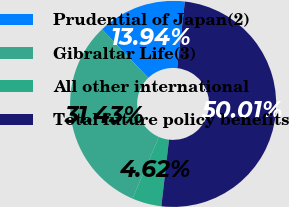Convert chart to OTSL. <chart><loc_0><loc_0><loc_500><loc_500><pie_chart><fcel>Prudential of Japan(2)<fcel>Gibraltar Life(3)<fcel>All other international<fcel>Total future policy benefits<nl><fcel>13.94%<fcel>31.43%<fcel>4.62%<fcel>50.0%<nl></chart> 